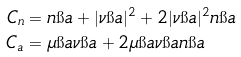Convert formula to latex. <formula><loc_0><loc_0><loc_500><loc_500>C _ { n } & = n \i a + | \nu \i a | ^ { 2 } + 2 | \nu \i a | ^ { 2 } n \i a \\ C _ { a } & = \mu \i a \nu \i a + 2 \mu \i a \nu \i a n \i a</formula> 